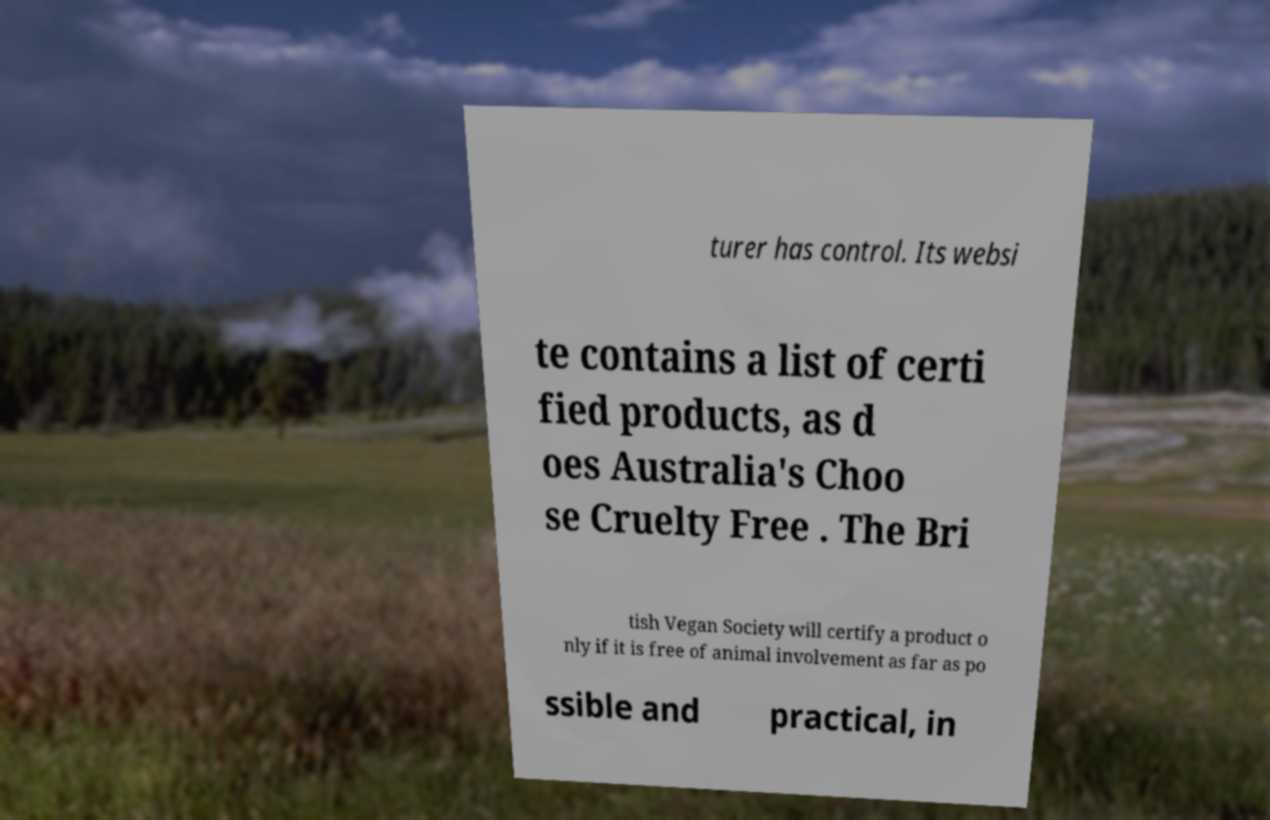I need the written content from this picture converted into text. Can you do that? turer has control. Its websi te contains a list of certi fied products, as d oes Australia's Choo se Cruelty Free . The Bri tish Vegan Society will certify a product o nly if it is free of animal involvement as far as po ssible and practical, in 